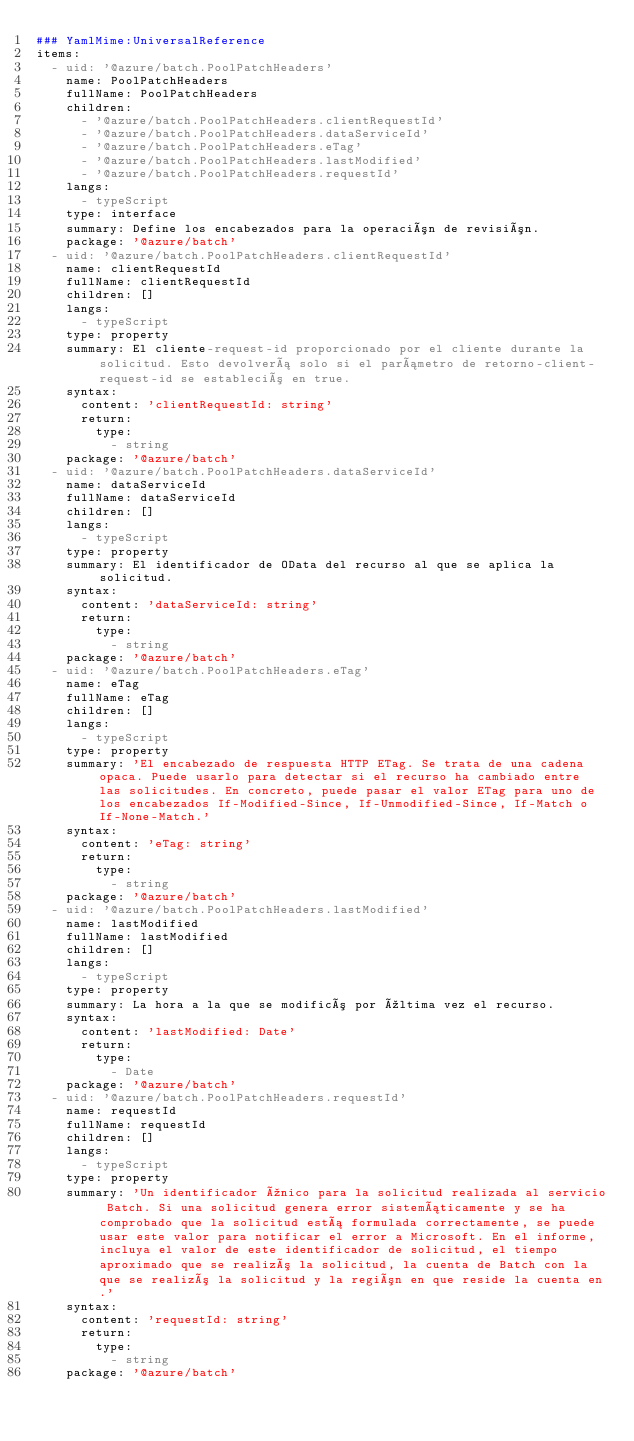<code> <loc_0><loc_0><loc_500><loc_500><_YAML_>### YamlMime:UniversalReference
items:
  - uid: '@azure/batch.PoolPatchHeaders'
    name: PoolPatchHeaders
    fullName: PoolPatchHeaders
    children:
      - '@azure/batch.PoolPatchHeaders.clientRequestId'
      - '@azure/batch.PoolPatchHeaders.dataServiceId'
      - '@azure/batch.PoolPatchHeaders.eTag'
      - '@azure/batch.PoolPatchHeaders.lastModified'
      - '@azure/batch.PoolPatchHeaders.requestId'
    langs:
      - typeScript
    type: interface
    summary: Define los encabezados para la operación de revisión.
    package: '@azure/batch'
  - uid: '@azure/batch.PoolPatchHeaders.clientRequestId'
    name: clientRequestId
    fullName: clientRequestId
    children: []
    langs:
      - typeScript
    type: property
    summary: El cliente-request-id proporcionado por el cliente durante la solicitud. Esto devolverá solo si el parámetro de retorno-client-request-id se estableció en true.
    syntax:
      content: 'clientRequestId: string'
      return:
        type:
          - string
    package: '@azure/batch'
  - uid: '@azure/batch.PoolPatchHeaders.dataServiceId'
    name: dataServiceId
    fullName: dataServiceId
    children: []
    langs:
      - typeScript
    type: property
    summary: El identificador de OData del recurso al que se aplica la solicitud.
    syntax:
      content: 'dataServiceId: string'
      return:
        type:
          - string
    package: '@azure/batch'
  - uid: '@azure/batch.PoolPatchHeaders.eTag'
    name: eTag
    fullName: eTag
    children: []
    langs:
      - typeScript
    type: property
    summary: 'El encabezado de respuesta HTTP ETag. Se trata de una cadena opaca. Puede usarlo para detectar si el recurso ha cambiado entre las solicitudes. En concreto, puede pasar el valor ETag para uno de los encabezados If-Modified-Since, If-Unmodified-Since, If-Match o If-None-Match.'
    syntax:
      content: 'eTag: string'
      return:
        type:
          - string
    package: '@azure/batch'
  - uid: '@azure/batch.PoolPatchHeaders.lastModified'
    name: lastModified
    fullName: lastModified
    children: []
    langs:
      - typeScript
    type: property
    summary: La hora a la que se modificó por última vez el recurso.
    syntax:
      content: 'lastModified: Date'
      return:
        type:
          - Date
    package: '@azure/batch'
  - uid: '@azure/batch.PoolPatchHeaders.requestId'
    name: requestId
    fullName: requestId
    children: []
    langs:
      - typeScript
    type: property
    summary: 'Un identificador único para la solicitud realizada al servicio Batch. Si una solicitud genera error sistemáticamente y se ha comprobado que la solicitud está formulada correctamente, se puede usar este valor para notificar el error a Microsoft. En el informe, incluya el valor de este identificador de solicitud, el tiempo aproximado que se realizó la solicitud, la cuenta de Batch con la que se realizó la solicitud y la región en que reside la cuenta en.'
    syntax:
      content: 'requestId: string'
      return:
        type:
          - string
    package: '@azure/batch'</code> 